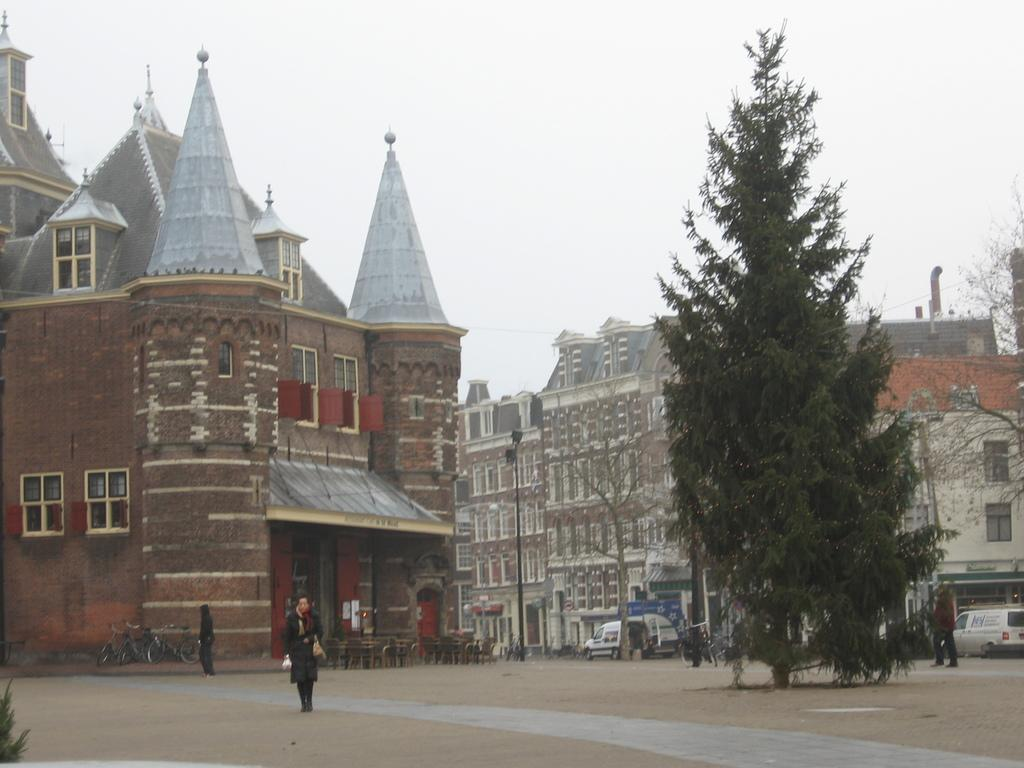How many people are in the image? There is a group of people in the image. What are the people doing in the image? The context is not specified, but they are likely engaged in an activity involving bicycles. What type of transportation can be seen in the image? There are bicycles and vehicles on the road in the image. What type of natural elements are present in the image? There are trees in the image. What type of man-made structures are present in the image? There are buildings in the image. What is visible in the background of the image? The sky is visible in the background of the image. How many babies are being stitched together in the image? There are no babies or stitching present in the image. What type of horn is being played by the people in the image? There is no horn or musical instrument being played by the people in the image. 